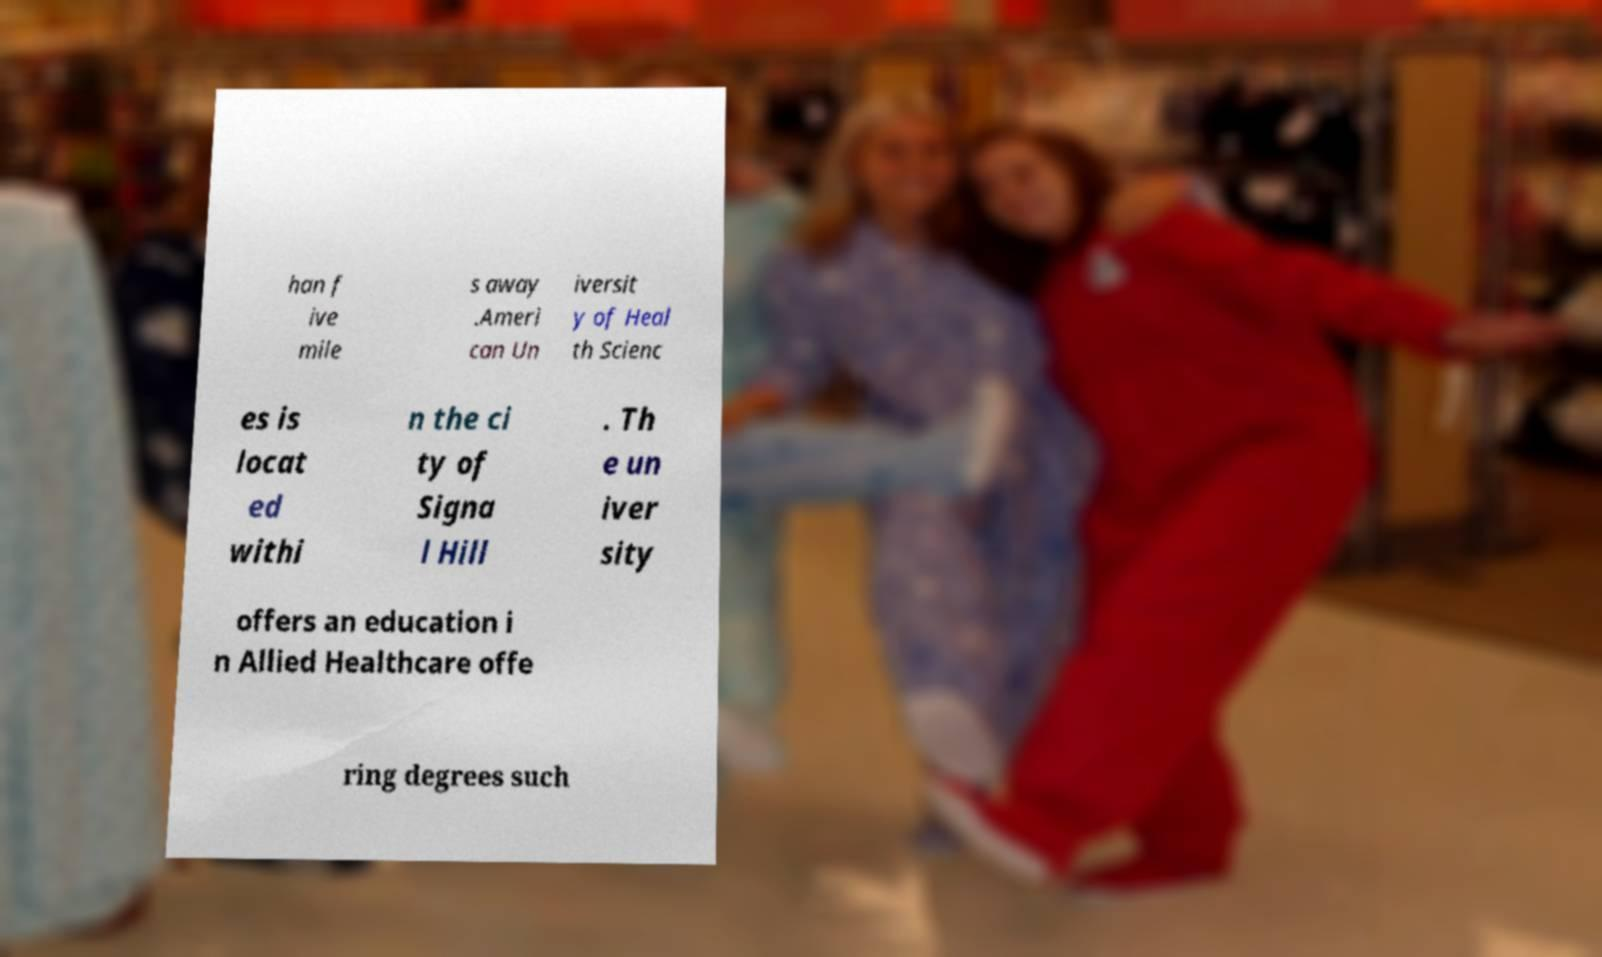Can you read and provide the text displayed in the image?This photo seems to have some interesting text. Can you extract and type it out for me? han f ive mile s away .Ameri can Un iversit y of Heal th Scienc es is locat ed withi n the ci ty of Signa l Hill . Th e un iver sity offers an education i n Allied Healthcare offe ring degrees such 